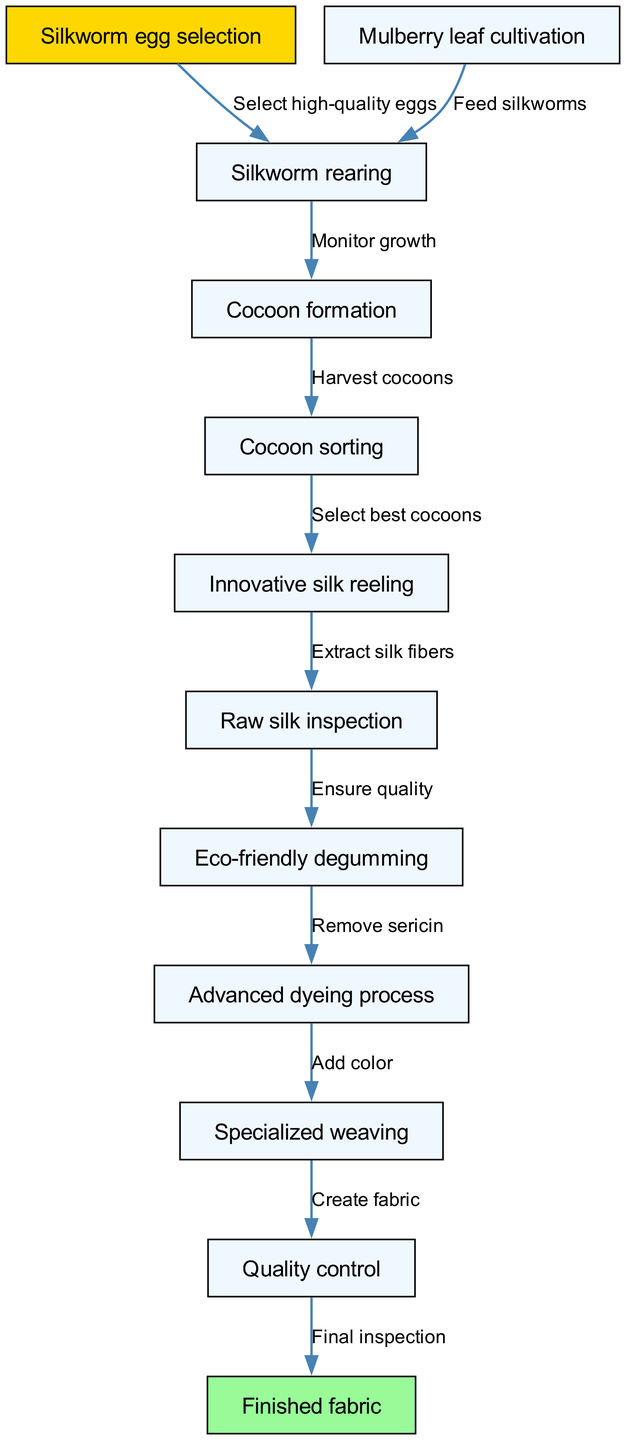What is the first step in the silk production process? The first step in the process is "Silkworm egg selection," as stated in the diagram's initial node.
Answer: Silkworm egg selection How many nodes are present in the diagram? By counting the nodes listed in the diagram, we find there are 12 nodes representing different steps in the silk production process.
Answer: 12 Which activity directly follows "Cocoon sorting"? Referring to the diagram's edges, "Cocoon sorting" is followed by "Innovative silk reeling," indicating the next action in the pathway.
Answer: Innovative silk reeling What is the final step before the finished fabric? The step immediately preceding "Finished fabric" is "Quality control," as shown in the connection indicated on the diagram.
Answer: Quality control What is the relationship between "Raw silk inspection" and "Eco-friendly degumming"? The diagram indicates a directional flow from "Raw silk inspection" to "Eco-friendly degumming," showing that after inspection, the next action is degumming the silk.
Answer: Ensure quality Which step involves the monitoring of silkworm growth? According to the diagram, "Silkworm rearing" is the step where the growth of silkworms is monitored as they feed on mulberry leaves.
Answer: Silkworm rearing How are cocoons harvested? The diagram indicates that cocoons are harvested following the "Cocoon formation" step, labeled as "Harvest cocoons".
Answer: Harvest cocoons What process is described as removing sericin from the silk? The step labeled "Eco-friendly degumming" specifically mentions the removal of sericin, which is a key part of processing raw silk.
Answer: Remove sericin What connects "Advanced dyeing process" to "Specialized weaving"? The connection from "Advanced dyeing process" to "Specialized weaving" is about adding color, indicating the importance of dyeing before weaving.
Answer: Add color 